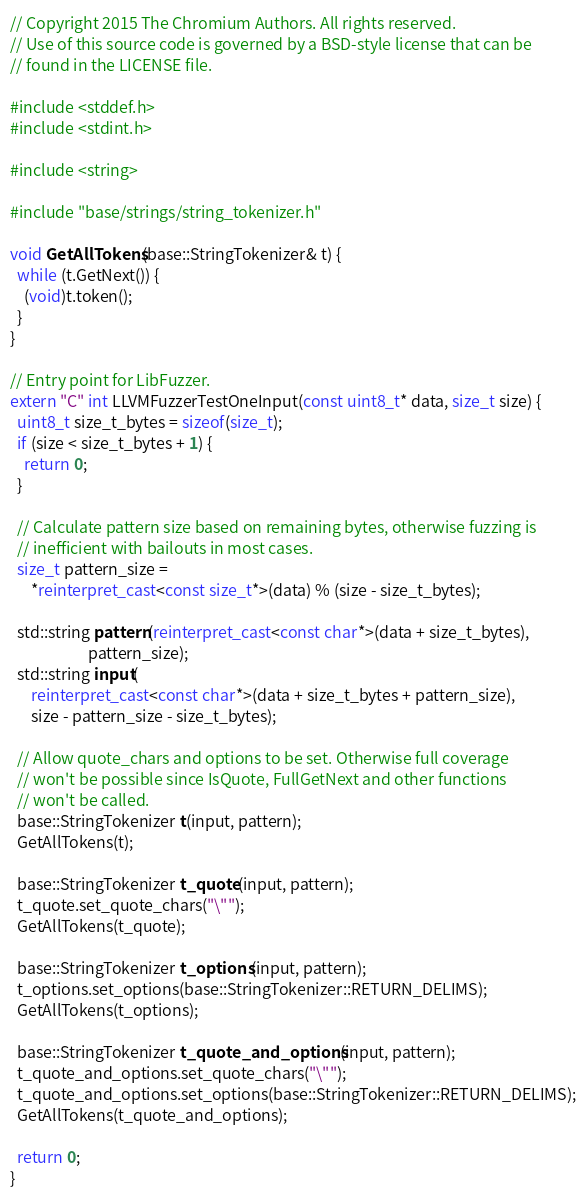<code> <loc_0><loc_0><loc_500><loc_500><_C++_>// Copyright 2015 The Chromium Authors. All rights reserved.
// Use of this source code is governed by a BSD-style license that can be
// found in the LICENSE file.

#include <stddef.h>
#include <stdint.h>

#include <string>

#include "base/strings/string_tokenizer.h"

void GetAllTokens(base::StringTokenizer& t) {
  while (t.GetNext()) {
    (void)t.token();
  }
}

// Entry point for LibFuzzer.
extern "C" int LLVMFuzzerTestOneInput(const uint8_t* data, size_t size) {
  uint8_t size_t_bytes = sizeof(size_t);
  if (size < size_t_bytes + 1) {
    return 0;
  }

  // Calculate pattern size based on remaining bytes, otherwise fuzzing is
  // inefficient with bailouts in most cases.
  size_t pattern_size =
      *reinterpret_cast<const size_t*>(data) % (size - size_t_bytes);

  std::string pattern(reinterpret_cast<const char*>(data + size_t_bytes),
                      pattern_size);
  std::string input(
      reinterpret_cast<const char*>(data + size_t_bytes + pattern_size),
      size - pattern_size - size_t_bytes);

  // Allow quote_chars and options to be set. Otherwise full coverage
  // won't be possible since IsQuote, FullGetNext and other functions
  // won't be called.
  base::StringTokenizer t(input, pattern);
  GetAllTokens(t);

  base::StringTokenizer t_quote(input, pattern);
  t_quote.set_quote_chars("\"");
  GetAllTokens(t_quote);

  base::StringTokenizer t_options(input, pattern);
  t_options.set_options(base::StringTokenizer::RETURN_DELIMS);
  GetAllTokens(t_options);

  base::StringTokenizer t_quote_and_options(input, pattern);
  t_quote_and_options.set_quote_chars("\"");
  t_quote_and_options.set_options(base::StringTokenizer::RETURN_DELIMS);
  GetAllTokens(t_quote_and_options);

  return 0;
}
</code> 